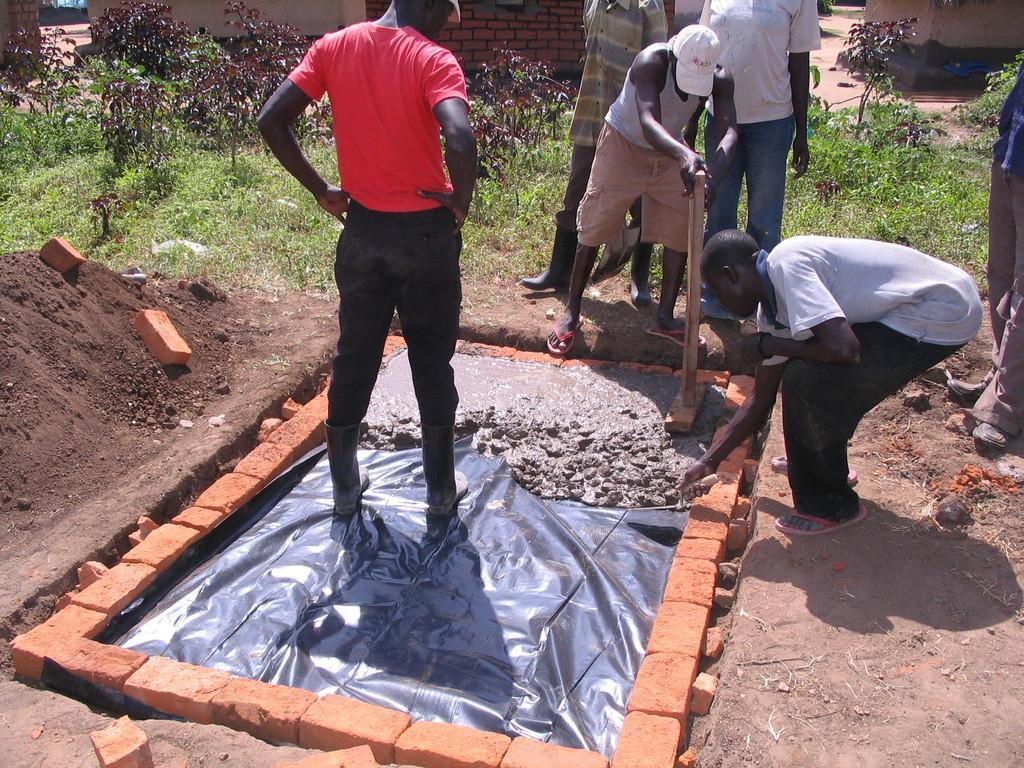How would you summarize this image in a sentence or two? In this picture we can see people on the ground, here we can see bricks, sheet, soil and some objects and in the background we can see plants, wall and some objects. 